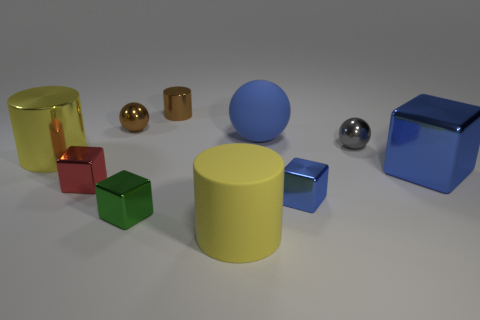How big is the block that is behind the tiny blue cube and to the left of the large blue rubber object?
Give a very brief answer. Small. Is the number of big blue rubber spheres right of the blue sphere less than the number of blue metal blocks?
Your response must be concise. Yes. What is the shape of the gray object that is the same material as the red cube?
Offer a terse response. Sphere. There is a large shiny object left of the tiny red object; is it the same shape as the tiny gray metal object to the right of the green metal block?
Your answer should be very brief. No. Is the number of big yellow matte things that are to the right of the tiny blue metal thing less than the number of green things that are to the right of the small green block?
Your response must be concise. No. There is a tiny thing that is the same color as the large shiny cube; what is its shape?
Ensure brevity in your answer.  Cube. How many rubber spheres are the same size as the gray shiny object?
Your answer should be very brief. 0. Do the large yellow object that is right of the small brown cylinder and the small green thing have the same material?
Your answer should be compact. No. Is there a tiny blue block?
Your answer should be very brief. Yes. What is the size of the gray ball that is the same material as the large blue cube?
Make the answer very short. Small. 